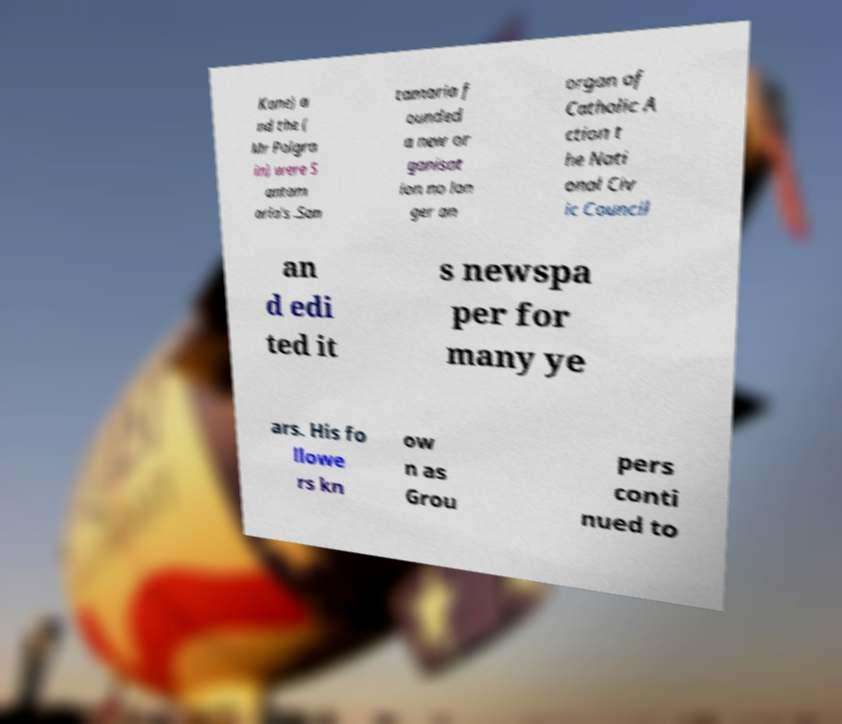Please identify and transcribe the text found in this image. Kane) a nd the ( Mr Polgra in) were S antam aria's .San tamaria f ounded a new or ganisat ion no lon ger an organ of Catholic A ction t he Nati onal Civ ic Council an d edi ted it s newspa per for many ye ars. His fo llowe rs kn ow n as Grou pers conti nued to 